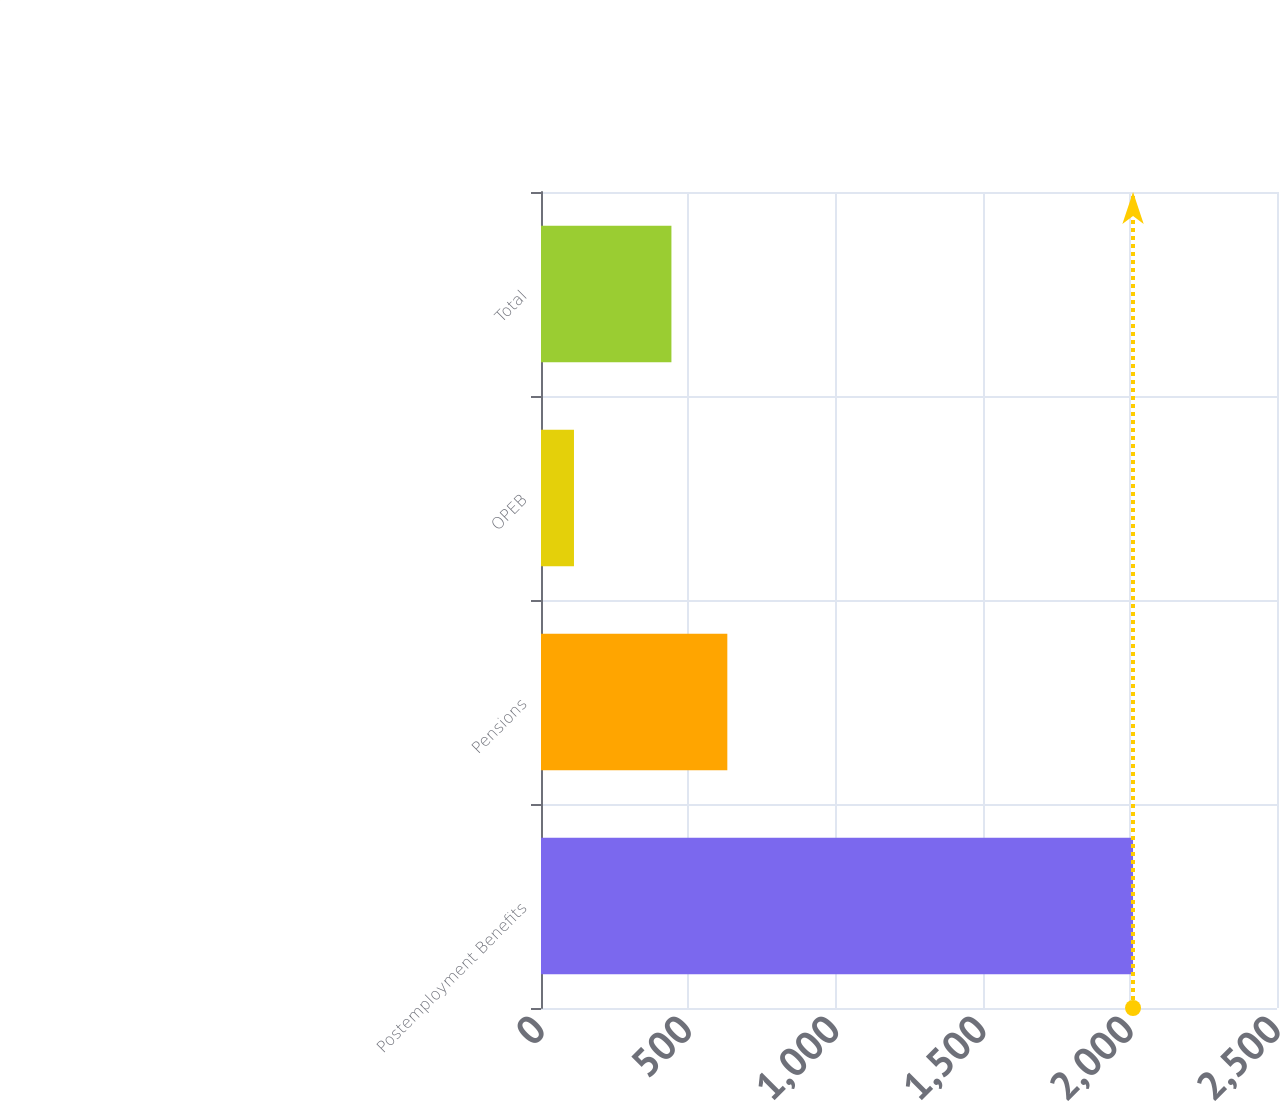Convert chart. <chart><loc_0><loc_0><loc_500><loc_500><bar_chart><fcel>Postemployment Benefits<fcel>Pensions<fcel>OPEB<fcel>Total<nl><fcel>2011<fcel>632.9<fcel>112<fcel>443<nl></chart> 